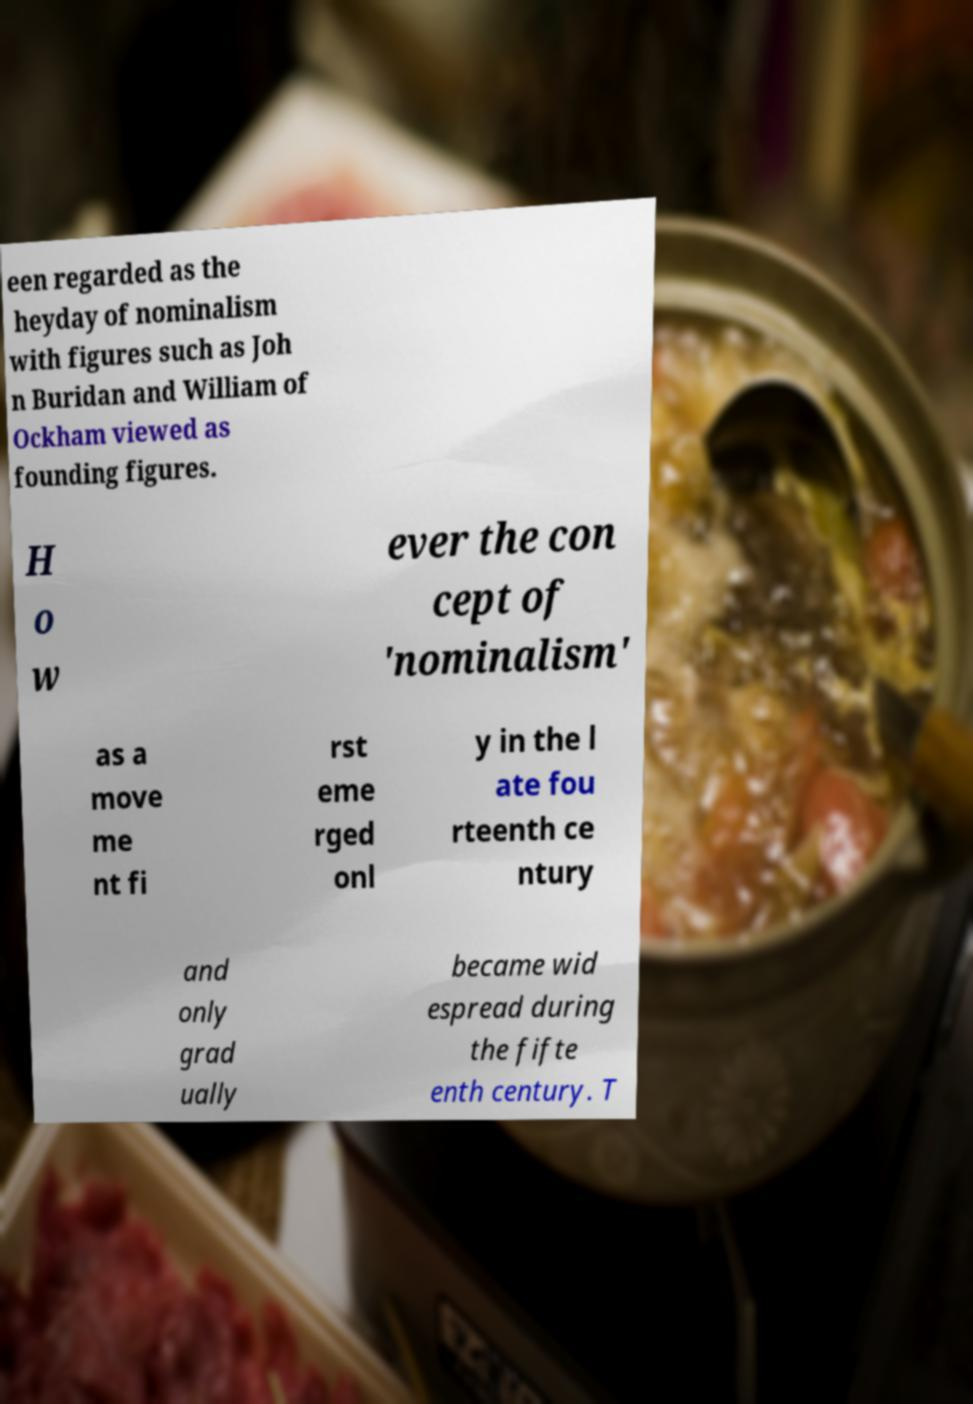Could you assist in decoding the text presented in this image and type it out clearly? een regarded as the heyday of nominalism with figures such as Joh n Buridan and William of Ockham viewed as founding figures. H o w ever the con cept of 'nominalism' as a move me nt fi rst eme rged onl y in the l ate fou rteenth ce ntury and only grad ually became wid espread during the fifte enth century. T 